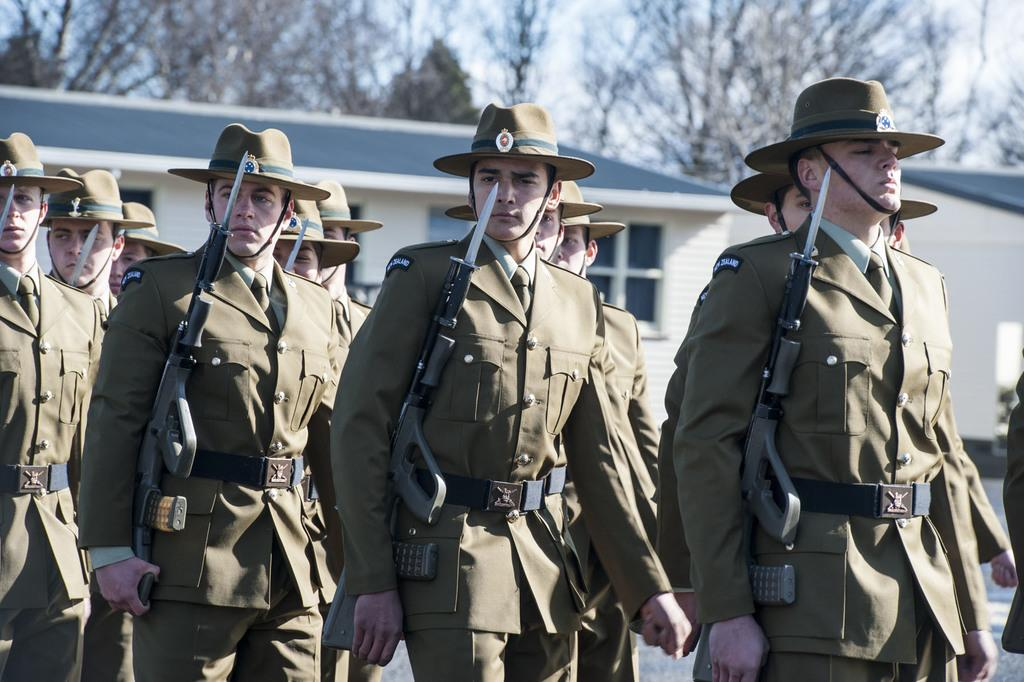How many people are in the image? There are people in the image, but the exact number is not specified. What are the people wearing on their heads? The people in the image are wearing hats. What are some people holding in the image? Some people are holding guns in the image. What can be seen in the background of the image? In the background, there are buildings with windows, trees, and the sky. What type of brake can be seen on the bushes in the image? There are no bushes or brakes present in the image. How does the wash affect the people in the image? There is no mention of a wash or its effect on the people in the image. 